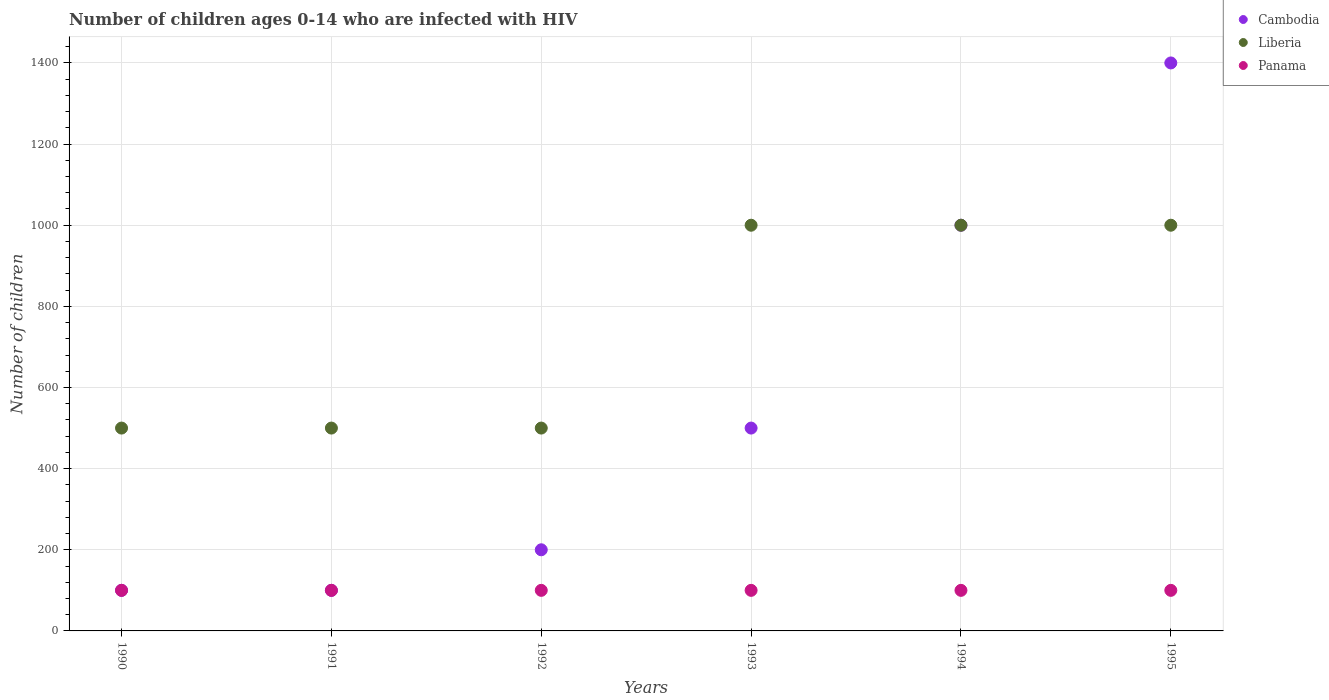How many different coloured dotlines are there?
Provide a succinct answer. 3. Is the number of dotlines equal to the number of legend labels?
Your response must be concise. Yes. What is the number of HIV infected children in Panama in 1990?
Your answer should be compact. 100. Across all years, what is the maximum number of HIV infected children in Cambodia?
Your answer should be very brief. 1400. Across all years, what is the minimum number of HIV infected children in Panama?
Give a very brief answer. 100. In which year was the number of HIV infected children in Panama minimum?
Your answer should be very brief. 1990. What is the total number of HIV infected children in Liberia in the graph?
Ensure brevity in your answer.  4500. What is the difference between the number of HIV infected children in Panama in 1990 and that in 1992?
Your answer should be compact. 0. What is the difference between the number of HIV infected children in Liberia in 1993 and the number of HIV infected children in Panama in 1990?
Offer a terse response. 900. What is the average number of HIV infected children in Cambodia per year?
Keep it short and to the point. 550. In the year 1992, what is the difference between the number of HIV infected children in Panama and number of HIV infected children in Cambodia?
Provide a short and direct response. -100. What is the ratio of the number of HIV infected children in Panama in 1992 to that in 1993?
Offer a very short reply. 1. Is the number of HIV infected children in Cambodia in 1993 less than that in 1994?
Give a very brief answer. Yes. Is the difference between the number of HIV infected children in Panama in 1990 and 1991 greater than the difference between the number of HIV infected children in Cambodia in 1990 and 1991?
Your answer should be compact. No. What is the difference between the highest and the lowest number of HIV infected children in Cambodia?
Your answer should be compact. 1300. Is it the case that in every year, the sum of the number of HIV infected children in Panama and number of HIV infected children in Liberia  is greater than the number of HIV infected children in Cambodia?
Offer a terse response. No. Is the number of HIV infected children in Liberia strictly less than the number of HIV infected children in Panama over the years?
Offer a very short reply. No. Where does the legend appear in the graph?
Offer a very short reply. Top right. How many legend labels are there?
Give a very brief answer. 3. How are the legend labels stacked?
Ensure brevity in your answer.  Vertical. What is the title of the graph?
Provide a succinct answer. Number of children ages 0-14 who are infected with HIV. What is the label or title of the X-axis?
Offer a very short reply. Years. What is the label or title of the Y-axis?
Make the answer very short. Number of children. What is the Number of children of Cambodia in 1990?
Give a very brief answer. 100. What is the Number of children of Liberia in 1990?
Make the answer very short. 500. What is the Number of children in Liberia in 1991?
Provide a short and direct response. 500. What is the Number of children in Liberia in 1992?
Your answer should be very brief. 500. What is the Number of children in Panama in 1992?
Make the answer very short. 100. What is the Number of children in Cambodia in 1993?
Provide a succinct answer. 500. What is the Number of children of Panama in 1993?
Ensure brevity in your answer.  100. What is the Number of children of Liberia in 1994?
Provide a succinct answer. 1000. What is the Number of children of Cambodia in 1995?
Your answer should be very brief. 1400. Across all years, what is the maximum Number of children in Cambodia?
Provide a short and direct response. 1400. What is the total Number of children in Cambodia in the graph?
Ensure brevity in your answer.  3300. What is the total Number of children of Liberia in the graph?
Your answer should be very brief. 4500. What is the total Number of children in Panama in the graph?
Provide a succinct answer. 600. What is the difference between the Number of children of Cambodia in 1990 and that in 1992?
Your response must be concise. -100. What is the difference between the Number of children in Cambodia in 1990 and that in 1993?
Offer a terse response. -400. What is the difference between the Number of children of Liberia in 1990 and that in 1993?
Offer a terse response. -500. What is the difference between the Number of children in Cambodia in 1990 and that in 1994?
Offer a very short reply. -900. What is the difference between the Number of children in Liberia in 1990 and that in 1994?
Your response must be concise. -500. What is the difference between the Number of children of Cambodia in 1990 and that in 1995?
Your answer should be compact. -1300. What is the difference between the Number of children of Liberia in 1990 and that in 1995?
Give a very brief answer. -500. What is the difference between the Number of children in Cambodia in 1991 and that in 1992?
Make the answer very short. -100. What is the difference between the Number of children in Cambodia in 1991 and that in 1993?
Provide a short and direct response. -400. What is the difference between the Number of children of Liberia in 1991 and that in 1993?
Your answer should be very brief. -500. What is the difference between the Number of children of Panama in 1991 and that in 1993?
Give a very brief answer. 0. What is the difference between the Number of children of Cambodia in 1991 and that in 1994?
Your answer should be very brief. -900. What is the difference between the Number of children of Liberia in 1991 and that in 1994?
Ensure brevity in your answer.  -500. What is the difference between the Number of children in Cambodia in 1991 and that in 1995?
Ensure brevity in your answer.  -1300. What is the difference between the Number of children in Liberia in 1991 and that in 1995?
Offer a terse response. -500. What is the difference between the Number of children in Cambodia in 1992 and that in 1993?
Provide a succinct answer. -300. What is the difference between the Number of children in Liberia in 1992 and that in 1993?
Provide a succinct answer. -500. What is the difference between the Number of children of Cambodia in 1992 and that in 1994?
Offer a terse response. -800. What is the difference between the Number of children of Liberia in 1992 and that in 1994?
Give a very brief answer. -500. What is the difference between the Number of children of Cambodia in 1992 and that in 1995?
Provide a succinct answer. -1200. What is the difference between the Number of children of Liberia in 1992 and that in 1995?
Ensure brevity in your answer.  -500. What is the difference between the Number of children in Panama in 1992 and that in 1995?
Your answer should be compact. 0. What is the difference between the Number of children of Cambodia in 1993 and that in 1994?
Offer a terse response. -500. What is the difference between the Number of children of Cambodia in 1993 and that in 1995?
Provide a short and direct response. -900. What is the difference between the Number of children of Cambodia in 1994 and that in 1995?
Provide a succinct answer. -400. What is the difference between the Number of children in Cambodia in 1990 and the Number of children in Liberia in 1991?
Ensure brevity in your answer.  -400. What is the difference between the Number of children of Cambodia in 1990 and the Number of children of Liberia in 1992?
Keep it short and to the point. -400. What is the difference between the Number of children of Cambodia in 1990 and the Number of children of Panama in 1992?
Make the answer very short. 0. What is the difference between the Number of children in Cambodia in 1990 and the Number of children in Liberia in 1993?
Give a very brief answer. -900. What is the difference between the Number of children in Cambodia in 1990 and the Number of children in Panama in 1993?
Your answer should be compact. 0. What is the difference between the Number of children in Liberia in 1990 and the Number of children in Panama in 1993?
Make the answer very short. 400. What is the difference between the Number of children in Cambodia in 1990 and the Number of children in Liberia in 1994?
Provide a succinct answer. -900. What is the difference between the Number of children in Cambodia in 1990 and the Number of children in Panama in 1994?
Make the answer very short. 0. What is the difference between the Number of children of Cambodia in 1990 and the Number of children of Liberia in 1995?
Provide a short and direct response. -900. What is the difference between the Number of children of Cambodia in 1990 and the Number of children of Panama in 1995?
Your answer should be compact. 0. What is the difference between the Number of children in Cambodia in 1991 and the Number of children in Liberia in 1992?
Offer a terse response. -400. What is the difference between the Number of children in Cambodia in 1991 and the Number of children in Panama in 1992?
Give a very brief answer. 0. What is the difference between the Number of children of Liberia in 1991 and the Number of children of Panama in 1992?
Offer a terse response. 400. What is the difference between the Number of children in Cambodia in 1991 and the Number of children in Liberia in 1993?
Make the answer very short. -900. What is the difference between the Number of children in Liberia in 1991 and the Number of children in Panama in 1993?
Your answer should be very brief. 400. What is the difference between the Number of children of Cambodia in 1991 and the Number of children of Liberia in 1994?
Provide a short and direct response. -900. What is the difference between the Number of children in Cambodia in 1991 and the Number of children in Panama in 1994?
Give a very brief answer. 0. What is the difference between the Number of children of Liberia in 1991 and the Number of children of Panama in 1994?
Provide a succinct answer. 400. What is the difference between the Number of children of Cambodia in 1991 and the Number of children of Liberia in 1995?
Offer a terse response. -900. What is the difference between the Number of children of Cambodia in 1991 and the Number of children of Panama in 1995?
Keep it short and to the point. 0. What is the difference between the Number of children of Cambodia in 1992 and the Number of children of Liberia in 1993?
Provide a short and direct response. -800. What is the difference between the Number of children of Cambodia in 1992 and the Number of children of Panama in 1993?
Ensure brevity in your answer.  100. What is the difference between the Number of children in Liberia in 1992 and the Number of children in Panama in 1993?
Provide a succinct answer. 400. What is the difference between the Number of children of Cambodia in 1992 and the Number of children of Liberia in 1994?
Provide a succinct answer. -800. What is the difference between the Number of children of Cambodia in 1992 and the Number of children of Panama in 1994?
Offer a terse response. 100. What is the difference between the Number of children in Liberia in 1992 and the Number of children in Panama in 1994?
Your answer should be compact. 400. What is the difference between the Number of children in Cambodia in 1992 and the Number of children in Liberia in 1995?
Keep it short and to the point. -800. What is the difference between the Number of children of Cambodia in 1992 and the Number of children of Panama in 1995?
Offer a very short reply. 100. What is the difference between the Number of children in Liberia in 1992 and the Number of children in Panama in 1995?
Provide a short and direct response. 400. What is the difference between the Number of children in Cambodia in 1993 and the Number of children in Liberia in 1994?
Ensure brevity in your answer.  -500. What is the difference between the Number of children of Cambodia in 1993 and the Number of children of Panama in 1994?
Your response must be concise. 400. What is the difference between the Number of children in Liberia in 1993 and the Number of children in Panama in 1994?
Ensure brevity in your answer.  900. What is the difference between the Number of children in Cambodia in 1993 and the Number of children in Liberia in 1995?
Your response must be concise. -500. What is the difference between the Number of children of Cambodia in 1993 and the Number of children of Panama in 1995?
Your answer should be compact. 400. What is the difference between the Number of children of Liberia in 1993 and the Number of children of Panama in 1995?
Provide a succinct answer. 900. What is the difference between the Number of children of Cambodia in 1994 and the Number of children of Liberia in 1995?
Offer a very short reply. 0. What is the difference between the Number of children of Cambodia in 1994 and the Number of children of Panama in 1995?
Your answer should be compact. 900. What is the difference between the Number of children of Liberia in 1994 and the Number of children of Panama in 1995?
Keep it short and to the point. 900. What is the average Number of children of Cambodia per year?
Make the answer very short. 550. What is the average Number of children of Liberia per year?
Provide a succinct answer. 750. What is the average Number of children of Panama per year?
Make the answer very short. 100. In the year 1990, what is the difference between the Number of children of Cambodia and Number of children of Liberia?
Offer a terse response. -400. In the year 1990, what is the difference between the Number of children of Cambodia and Number of children of Panama?
Give a very brief answer. 0. In the year 1991, what is the difference between the Number of children in Cambodia and Number of children in Liberia?
Your response must be concise. -400. In the year 1991, what is the difference between the Number of children of Cambodia and Number of children of Panama?
Your answer should be very brief. 0. In the year 1992, what is the difference between the Number of children in Cambodia and Number of children in Liberia?
Provide a succinct answer. -300. In the year 1992, what is the difference between the Number of children in Cambodia and Number of children in Panama?
Offer a very short reply. 100. In the year 1993, what is the difference between the Number of children of Cambodia and Number of children of Liberia?
Keep it short and to the point. -500. In the year 1993, what is the difference between the Number of children of Liberia and Number of children of Panama?
Ensure brevity in your answer.  900. In the year 1994, what is the difference between the Number of children of Cambodia and Number of children of Liberia?
Offer a terse response. 0. In the year 1994, what is the difference between the Number of children of Cambodia and Number of children of Panama?
Keep it short and to the point. 900. In the year 1994, what is the difference between the Number of children in Liberia and Number of children in Panama?
Provide a succinct answer. 900. In the year 1995, what is the difference between the Number of children of Cambodia and Number of children of Panama?
Offer a very short reply. 1300. In the year 1995, what is the difference between the Number of children of Liberia and Number of children of Panama?
Make the answer very short. 900. What is the ratio of the Number of children of Panama in 1990 to that in 1991?
Your answer should be very brief. 1. What is the ratio of the Number of children in Liberia in 1990 to that in 1992?
Your answer should be compact. 1. What is the ratio of the Number of children of Panama in 1990 to that in 1992?
Your answer should be compact. 1. What is the ratio of the Number of children of Liberia in 1990 to that in 1993?
Keep it short and to the point. 0.5. What is the ratio of the Number of children in Cambodia in 1990 to that in 1994?
Ensure brevity in your answer.  0.1. What is the ratio of the Number of children in Cambodia in 1990 to that in 1995?
Make the answer very short. 0.07. What is the ratio of the Number of children of Liberia in 1990 to that in 1995?
Make the answer very short. 0.5. What is the ratio of the Number of children in Panama in 1990 to that in 1995?
Your response must be concise. 1. What is the ratio of the Number of children in Cambodia in 1991 to that in 1992?
Your answer should be very brief. 0.5. What is the ratio of the Number of children in Liberia in 1991 to that in 1992?
Ensure brevity in your answer.  1. What is the ratio of the Number of children in Panama in 1991 to that in 1992?
Give a very brief answer. 1. What is the ratio of the Number of children of Cambodia in 1991 to that in 1993?
Offer a terse response. 0.2. What is the ratio of the Number of children in Panama in 1991 to that in 1993?
Your response must be concise. 1. What is the ratio of the Number of children of Cambodia in 1991 to that in 1995?
Ensure brevity in your answer.  0.07. What is the ratio of the Number of children in Cambodia in 1992 to that in 1993?
Provide a succinct answer. 0.4. What is the ratio of the Number of children of Liberia in 1992 to that in 1993?
Keep it short and to the point. 0.5. What is the ratio of the Number of children in Cambodia in 1992 to that in 1994?
Make the answer very short. 0.2. What is the ratio of the Number of children in Cambodia in 1992 to that in 1995?
Ensure brevity in your answer.  0.14. What is the ratio of the Number of children of Cambodia in 1993 to that in 1994?
Make the answer very short. 0.5. What is the ratio of the Number of children in Liberia in 1993 to that in 1994?
Give a very brief answer. 1. What is the ratio of the Number of children of Cambodia in 1993 to that in 1995?
Give a very brief answer. 0.36. What is the ratio of the Number of children of Liberia in 1993 to that in 1995?
Offer a terse response. 1. What is the ratio of the Number of children in Liberia in 1994 to that in 1995?
Provide a succinct answer. 1. What is the difference between the highest and the second highest Number of children in Liberia?
Offer a very short reply. 0. What is the difference between the highest and the second highest Number of children of Panama?
Your answer should be very brief. 0. What is the difference between the highest and the lowest Number of children in Cambodia?
Provide a short and direct response. 1300. What is the difference between the highest and the lowest Number of children in Liberia?
Offer a very short reply. 500. 